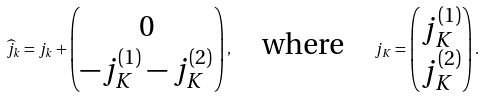Convert formula to latex. <formula><loc_0><loc_0><loc_500><loc_500>\widehat { j } _ { k } = j _ { k } + \begin{pmatrix} 0 \\ - j _ { K } ^ { ( 1 ) } - j _ { K } ^ { ( 2 ) } \end{pmatrix} , \quad \text {where} \quad j _ { K } = \begin{pmatrix} j _ { K } ^ { ( 1 ) } \\ j _ { K } ^ { ( 2 ) } \end{pmatrix} .</formula> 